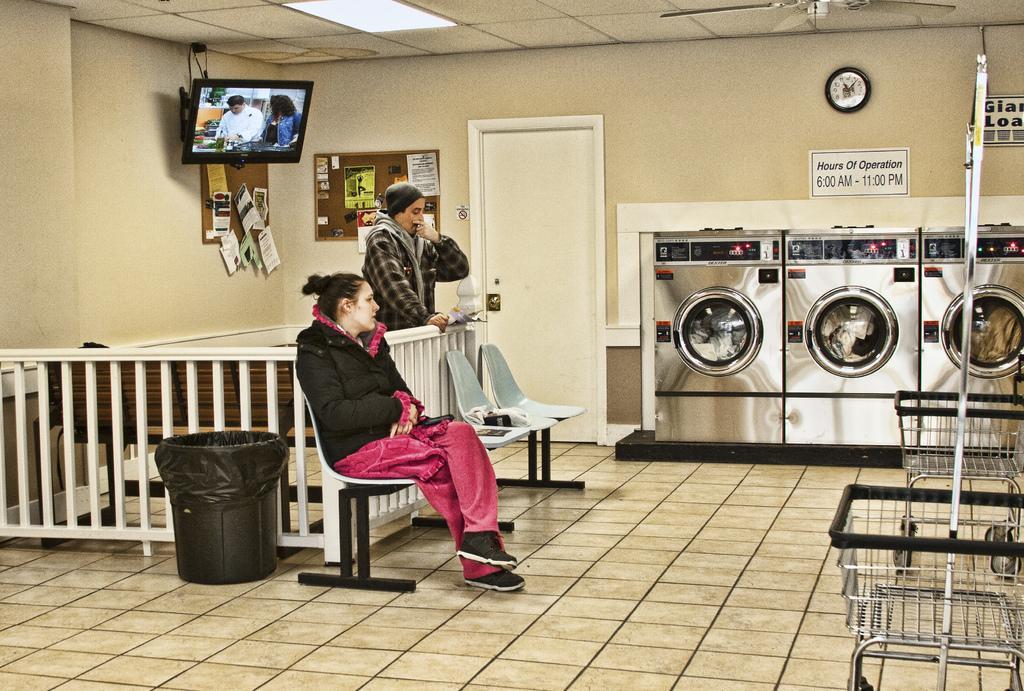How would you summarize this image in a sentence or two? On the background we can see notice board and papers over a wall and also a clock and here we can see television. This is a ceiling, fan and light. Here we can see a door. Here we can see few machines. Here we can see one woman sitting on a chair. This is a trash can. We can see one person standing here. These are cart wheels. 